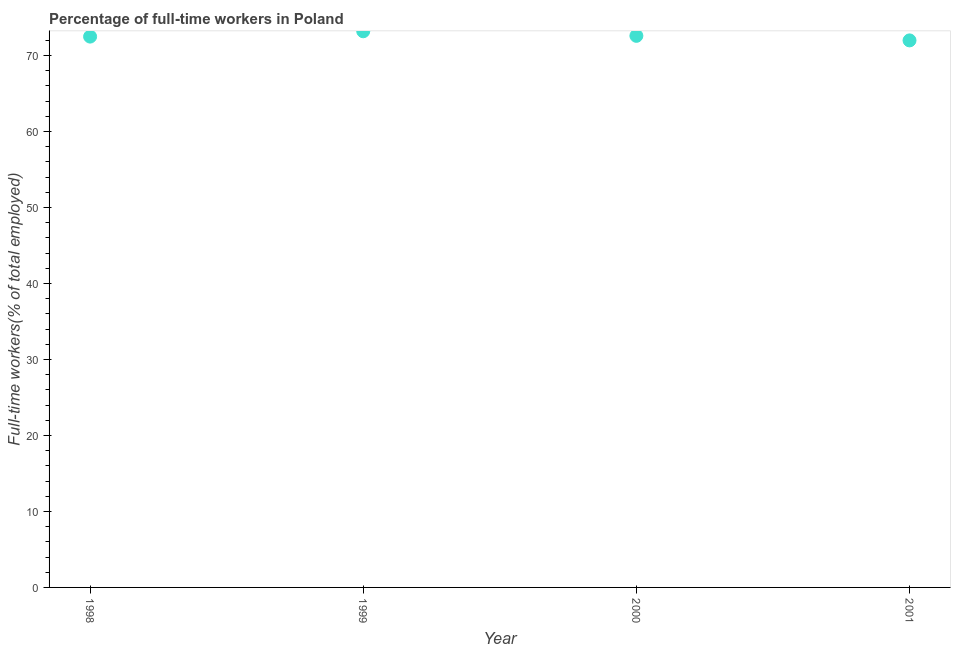What is the percentage of full-time workers in 2001?
Provide a short and direct response. 72. Across all years, what is the maximum percentage of full-time workers?
Your answer should be very brief. 73.2. Across all years, what is the minimum percentage of full-time workers?
Ensure brevity in your answer.  72. What is the sum of the percentage of full-time workers?
Your response must be concise. 290.3. What is the difference between the percentage of full-time workers in 1998 and 1999?
Your answer should be compact. -0.7. What is the average percentage of full-time workers per year?
Give a very brief answer. 72.57. What is the median percentage of full-time workers?
Your response must be concise. 72.55. In how many years, is the percentage of full-time workers greater than 42 %?
Offer a very short reply. 4. What is the ratio of the percentage of full-time workers in 1998 to that in 2000?
Your answer should be very brief. 1. What is the difference between the highest and the second highest percentage of full-time workers?
Your answer should be very brief. 0.6. Is the sum of the percentage of full-time workers in 1999 and 2001 greater than the maximum percentage of full-time workers across all years?
Offer a very short reply. Yes. What is the difference between the highest and the lowest percentage of full-time workers?
Give a very brief answer. 1.2. In how many years, is the percentage of full-time workers greater than the average percentage of full-time workers taken over all years?
Your response must be concise. 2. How many years are there in the graph?
Your answer should be very brief. 4. What is the difference between two consecutive major ticks on the Y-axis?
Keep it short and to the point. 10. Are the values on the major ticks of Y-axis written in scientific E-notation?
Your answer should be compact. No. Does the graph contain grids?
Ensure brevity in your answer.  No. What is the title of the graph?
Keep it short and to the point. Percentage of full-time workers in Poland. What is the label or title of the Y-axis?
Give a very brief answer. Full-time workers(% of total employed). What is the Full-time workers(% of total employed) in 1998?
Ensure brevity in your answer.  72.5. What is the Full-time workers(% of total employed) in 1999?
Provide a succinct answer. 73.2. What is the Full-time workers(% of total employed) in 2000?
Provide a short and direct response. 72.6. What is the Full-time workers(% of total employed) in 2001?
Give a very brief answer. 72. What is the difference between the Full-time workers(% of total employed) in 1998 and 1999?
Make the answer very short. -0.7. What is the ratio of the Full-time workers(% of total employed) in 1999 to that in 2000?
Your answer should be compact. 1.01. What is the ratio of the Full-time workers(% of total employed) in 1999 to that in 2001?
Offer a very short reply. 1.02. What is the ratio of the Full-time workers(% of total employed) in 2000 to that in 2001?
Keep it short and to the point. 1.01. 